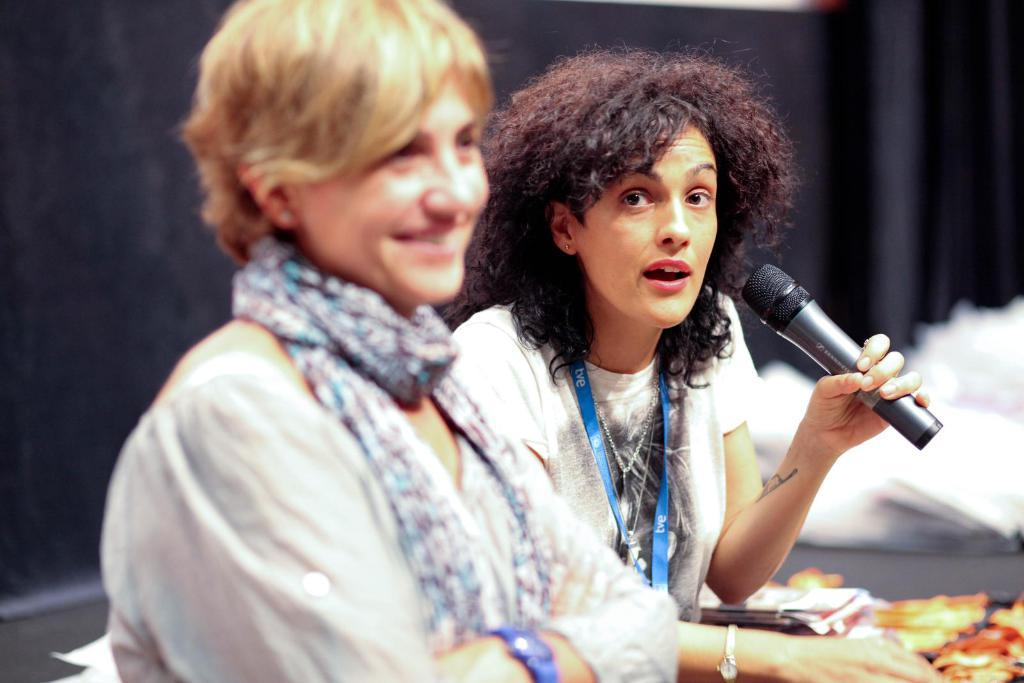How many people are in the image? There are two persons in the image. What is the appearance of the person wearing a stole? The person wearing a stole is smiling and has it around their neck. What is the other person holding? The other person is holding a microphone. What is the person with the microphone doing? The person with the microphone is talking. Can you see the person's toes in the image? There is no information about the person's toes in the image, so it cannot be determined if they are visible. 